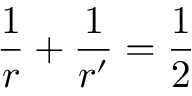<formula> <loc_0><loc_0><loc_500><loc_500>\frac { 1 } { r } + \frac { 1 } { r ^ { \prime } } = \frac { 1 } { 2 }</formula> 